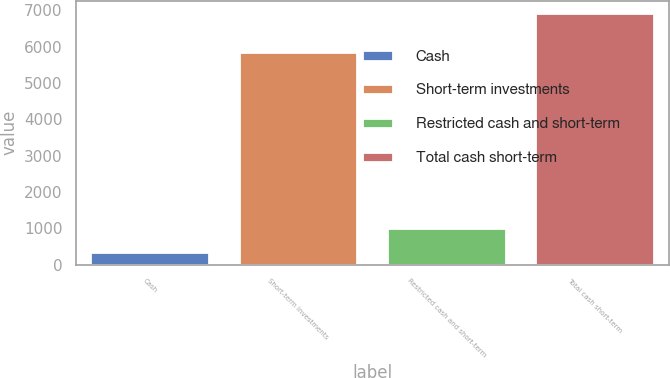<chart> <loc_0><loc_0><loc_500><loc_500><bar_chart><fcel>Cash<fcel>Short-term investments<fcel>Restricted cash and short-term<fcel>Total cash short-term<nl><fcel>364<fcel>5862<fcel>1019.7<fcel>6921<nl></chart> 